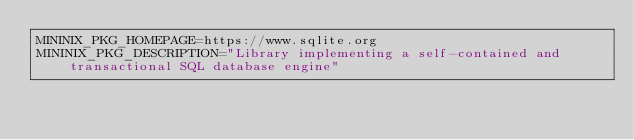<code> <loc_0><loc_0><loc_500><loc_500><_Bash_>MININIX_PKG_HOMEPAGE=https://www.sqlite.org
MININIX_PKG_DESCRIPTION="Library implementing a self-contained and transactional SQL database engine"</code> 